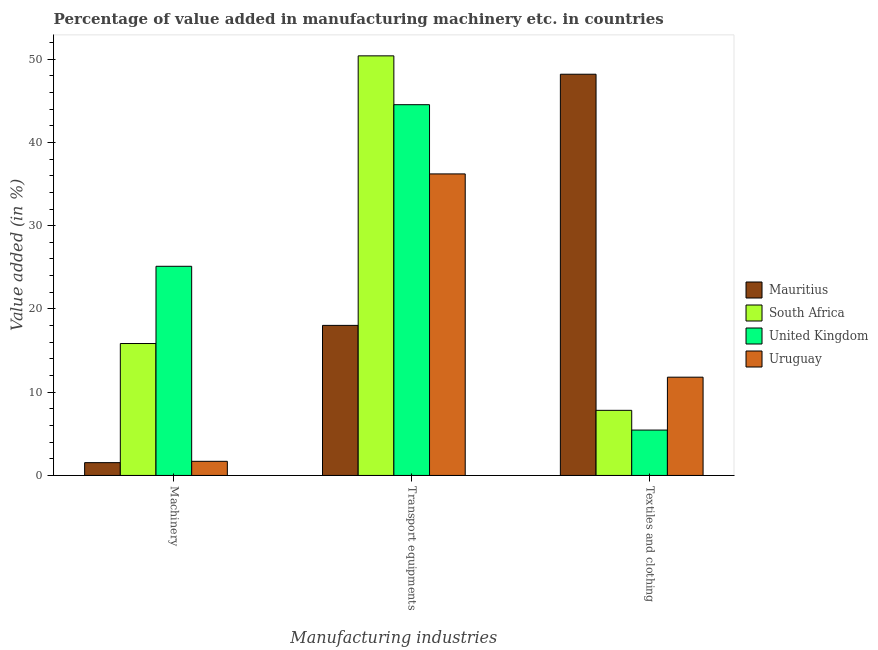Are the number of bars on each tick of the X-axis equal?
Offer a very short reply. Yes. How many bars are there on the 2nd tick from the left?
Keep it short and to the point. 4. What is the label of the 2nd group of bars from the left?
Your response must be concise. Transport equipments. What is the value added in manufacturing textile and clothing in Mauritius?
Give a very brief answer. 48.19. Across all countries, what is the maximum value added in manufacturing transport equipments?
Your answer should be very brief. 50.4. Across all countries, what is the minimum value added in manufacturing machinery?
Offer a very short reply. 1.54. In which country was the value added in manufacturing transport equipments maximum?
Ensure brevity in your answer.  South Africa. In which country was the value added in manufacturing machinery minimum?
Your answer should be compact. Mauritius. What is the total value added in manufacturing machinery in the graph?
Provide a short and direct response. 44.2. What is the difference between the value added in manufacturing transport equipments in Mauritius and that in South Africa?
Your answer should be compact. -32.38. What is the difference between the value added in manufacturing transport equipments in South Africa and the value added in manufacturing textile and clothing in Uruguay?
Your answer should be very brief. 38.6. What is the average value added in manufacturing textile and clothing per country?
Your answer should be very brief. 18.32. What is the difference between the value added in manufacturing machinery and value added in manufacturing transport equipments in Uruguay?
Your answer should be very brief. -34.52. What is the ratio of the value added in manufacturing textile and clothing in Mauritius to that in South Africa?
Ensure brevity in your answer.  6.16. What is the difference between the highest and the second highest value added in manufacturing transport equipments?
Keep it short and to the point. 5.87. What is the difference between the highest and the lowest value added in manufacturing transport equipments?
Offer a terse response. 32.38. In how many countries, is the value added in manufacturing transport equipments greater than the average value added in manufacturing transport equipments taken over all countries?
Give a very brief answer. 2. What does the 4th bar from the left in Transport equipments represents?
Provide a short and direct response. Uruguay. What does the 4th bar from the right in Machinery represents?
Your answer should be compact. Mauritius. Are all the bars in the graph horizontal?
Your answer should be very brief. No. How many countries are there in the graph?
Ensure brevity in your answer.  4. What is the difference between two consecutive major ticks on the Y-axis?
Your answer should be compact. 10. Does the graph contain any zero values?
Your answer should be compact. No. Where does the legend appear in the graph?
Provide a succinct answer. Center right. What is the title of the graph?
Provide a succinct answer. Percentage of value added in manufacturing machinery etc. in countries. What is the label or title of the X-axis?
Offer a terse response. Manufacturing industries. What is the label or title of the Y-axis?
Provide a short and direct response. Value added (in %). What is the Value added (in %) of Mauritius in Machinery?
Provide a short and direct response. 1.54. What is the Value added (in %) in South Africa in Machinery?
Provide a short and direct response. 15.85. What is the Value added (in %) in United Kingdom in Machinery?
Provide a short and direct response. 25.12. What is the Value added (in %) of Uruguay in Machinery?
Provide a short and direct response. 1.7. What is the Value added (in %) in Mauritius in Transport equipments?
Provide a succinct answer. 18.02. What is the Value added (in %) of South Africa in Transport equipments?
Provide a short and direct response. 50.4. What is the Value added (in %) in United Kingdom in Transport equipments?
Give a very brief answer. 44.53. What is the Value added (in %) in Uruguay in Transport equipments?
Provide a succinct answer. 36.22. What is the Value added (in %) in Mauritius in Textiles and clothing?
Your response must be concise. 48.19. What is the Value added (in %) in South Africa in Textiles and clothing?
Your answer should be compact. 7.82. What is the Value added (in %) of United Kingdom in Textiles and clothing?
Your answer should be compact. 5.45. What is the Value added (in %) in Uruguay in Textiles and clothing?
Provide a succinct answer. 11.8. Across all Manufacturing industries, what is the maximum Value added (in %) in Mauritius?
Offer a terse response. 48.19. Across all Manufacturing industries, what is the maximum Value added (in %) in South Africa?
Your answer should be compact. 50.4. Across all Manufacturing industries, what is the maximum Value added (in %) in United Kingdom?
Your answer should be very brief. 44.53. Across all Manufacturing industries, what is the maximum Value added (in %) in Uruguay?
Ensure brevity in your answer.  36.22. Across all Manufacturing industries, what is the minimum Value added (in %) in Mauritius?
Offer a terse response. 1.54. Across all Manufacturing industries, what is the minimum Value added (in %) in South Africa?
Your answer should be compact. 7.82. Across all Manufacturing industries, what is the minimum Value added (in %) in United Kingdom?
Your answer should be compact. 5.45. Across all Manufacturing industries, what is the minimum Value added (in %) of Uruguay?
Give a very brief answer. 1.7. What is the total Value added (in %) of Mauritius in the graph?
Provide a succinct answer. 67.75. What is the total Value added (in %) in South Africa in the graph?
Ensure brevity in your answer.  74.07. What is the total Value added (in %) in United Kingdom in the graph?
Provide a short and direct response. 75.1. What is the total Value added (in %) of Uruguay in the graph?
Provide a short and direct response. 49.72. What is the difference between the Value added (in %) of Mauritius in Machinery and that in Transport equipments?
Offer a terse response. -16.49. What is the difference between the Value added (in %) in South Africa in Machinery and that in Transport equipments?
Your response must be concise. -34.55. What is the difference between the Value added (in %) of United Kingdom in Machinery and that in Transport equipments?
Your response must be concise. -19.41. What is the difference between the Value added (in %) of Uruguay in Machinery and that in Transport equipments?
Ensure brevity in your answer.  -34.52. What is the difference between the Value added (in %) in Mauritius in Machinery and that in Textiles and clothing?
Your answer should be compact. -46.66. What is the difference between the Value added (in %) of South Africa in Machinery and that in Textiles and clothing?
Offer a very short reply. 8.03. What is the difference between the Value added (in %) in United Kingdom in Machinery and that in Textiles and clothing?
Ensure brevity in your answer.  19.67. What is the difference between the Value added (in %) of Uruguay in Machinery and that in Textiles and clothing?
Keep it short and to the point. -10.11. What is the difference between the Value added (in %) in Mauritius in Transport equipments and that in Textiles and clothing?
Make the answer very short. -30.17. What is the difference between the Value added (in %) in South Africa in Transport equipments and that in Textiles and clothing?
Provide a succinct answer. 42.58. What is the difference between the Value added (in %) in United Kingdom in Transport equipments and that in Textiles and clothing?
Your response must be concise. 39.08. What is the difference between the Value added (in %) of Uruguay in Transport equipments and that in Textiles and clothing?
Your answer should be compact. 24.42. What is the difference between the Value added (in %) in Mauritius in Machinery and the Value added (in %) in South Africa in Transport equipments?
Offer a terse response. -48.86. What is the difference between the Value added (in %) in Mauritius in Machinery and the Value added (in %) in United Kingdom in Transport equipments?
Offer a terse response. -43. What is the difference between the Value added (in %) in Mauritius in Machinery and the Value added (in %) in Uruguay in Transport equipments?
Offer a terse response. -34.68. What is the difference between the Value added (in %) in South Africa in Machinery and the Value added (in %) in United Kingdom in Transport equipments?
Offer a terse response. -28.69. What is the difference between the Value added (in %) in South Africa in Machinery and the Value added (in %) in Uruguay in Transport equipments?
Make the answer very short. -20.37. What is the difference between the Value added (in %) in United Kingdom in Machinery and the Value added (in %) in Uruguay in Transport equipments?
Provide a succinct answer. -11.1. What is the difference between the Value added (in %) of Mauritius in Machinery and the Value added (in %) of South Africa in Textiles and clothing?
Keep it short and to the point. -6.28. What is the difference between the Value added (in %) of Mauritius in Machinery and the Value added (in %) of United Kingdom in Textiles and clothing?
Ensure brevity in your answer.  -3.91. What is the difference between the Value added (in %) in Mauritius in Machinery and the Value added (in %) in Uruguay in Textiles and clothing?
Your answer should be compact. -10.27. What is the difference between the Value added (in %) in South Africa in Machinery and the Value added (in %) in United Kingdom in Textiles and clothing?
Keep it short and to the point. 10.4. What is the difference between the Value added (in %) in South Africa in Machinery and the Value added (in %) in Uruguay in Textiles and clothing?
Provide a succinct answer. 4.04. What is the difference between the Value added (in %) in United Kingdom in Machinery and the Value added (in %) in Uruguay in Textiles and clothing?
Provide a succinct answer. 13.32. What is the difference between the Value added (in %) in Mauritius in Transport equipments and the Value added (in %) in South Africa in Textiles and clothing?
Make the answer very short. 10.2. What is the difference between the Value added (in %) of Mauritius in Transport equipments and the Value added (in %) of United Kingdom in Textiles and clothing?
Ensure brevity in your answer.  12.57. What is the difference between the Value added (in %) in Mauritius in Transport equipments and the Value added (in %) in Uruguay in Textiles and clothing?
Make the answer very short. 6.22. What is the difference between the Value added (in %) in South Africa in Transport equipments and the Value added (in %) in United Kingdom in Textiles and clothing?
Your answer should be compact. 44.95. What is the difference between the Value added (in %) in South Africa in Transport equipments and the Value added (in %) in Uruguay in Textiles and clothing?
Offer a very short reply. 38.6. What is the difference between the Value added (in %) in United Kingdom in Transport equipments and the Value added (in %) in Uruguay in Textiles and clothing?
Provide a succinct answer. 32.73. What is the average Value added (in %) in Mauritius per Manufacturing industries?
Your answer should be compact. 22.58. What is the average Value added (in %) of South Africa per Manufacturing industries?
Your answer should be very brief. 24.69. What is the average Value added (in %) of United Kingdom per Manufacturing industries?
Your answer should be compact. 25.03. What is the average Value added (in %) of Uruguay per Manufacturing industries?
Offer a terse response. 16.57. What is the difference between the Value added (in %) of Mauritius and Value added (in %) of South Africa in Machinery?
Keep it short and to the point. -14.31. What is the difference between the Value added (in %) of Mauritius and Value added (in %) of United Kingdom in Machinery?
Your answer should be very brief. -23.59. What is the difference between the Value added (in %) in Mauritius and Value added (in %) in Uruguay in Machinery?
Give a very brief answer. -0.16. What is the difference between the Value added (in %) of South Africa and Value added (in %) of United Kingdom in Machinery?
Your answer should be very brief. -9.28. What is the difference between the Value added (in %) in South Africa and Value added (in %) in Uruguay in Machinery?
Keep it short and to the point. 14.15. What is the difference between the Value added (in %) of United Kingdom and Value added (in %) of Uruguay in Machinery?
Your answer should be compact. 23.43. What is the difference between the Value added (in %) of Mauritius and Value added (in %) of South Africa in Transport equipments?
Offer a terse response. -32.38. What is the difference between the Value added (in %) in Mauritius and Value added (in %) in United Kingdom in Transport equipments?
Give a very brief answer. -26.51. What is the difference between the Value added (in %) in Mauritius and Value added (in %) in Uruguay in Transport equipments?
Provide a short and direct response. -18.19. What is the difference between the Value added (in %) of South Africa and Value added (in %) of United Kingdom in Transport equipments?
Keep it short and to the point. 5.87. What is the difference between the Value added (in %) in South Africa and Value added (in %) in Uruguay in Transport equipments?
Your response must be concise. 14.18. What is the difference between the Value added (in %) of United Kingdom and Value added (in %) of Uruguay in Transport equipments?
Provide a short and direct response. 8.31. What is the difference between the Value added (in %) of Mauritius and Value added (in %) of South Africa in Textiles and clothing?
Provide a short and direct response. 40.37. What is the difference between the Value added (in %) of Mauritius and Value added (in %) of United Kingdom in Textiles and clothing?
Give a very brief answer. 42.74. What is the difference between the Value added (in %) in Mauritius and Value added (in %) in Uruguay in Textiles and clothing?
Provide a short and direct response. 36.39. What is the difference between the Value added (in %) in South Africa and Value added (in %) in United Kingdom in Textiles and clothing?
Offer a terse response. 2.37. What is the difference between the Value added (in %) of South Africa and Value added (in %) of Uruguay in Textiles and clothing?
Keep it short and to the point. -3.98. What is the difference between the Value added (in %) of United Kingdom and Value added (in %) of Uruguay in Textiles and clothing?
Keep it short and to the point. -6.35. What is the ratio of the Value added (in %) in Mauritius in Machinery to that in Transport equipments?
Ensure brevity in your answer.  0.09. What is the ratio of the Value added (in %) in South Africa in Machinery to that in Transport equipments?
Provide a short and direct response. 0.31. What is the ratio of the Value added (in %) of United Kingdom in Machinery to that in Transport equipments?
Provide a short and direct response. 0.56. What is the ratio of the Value added (in %) of Uruguay in Machinery to that in Transport equipments?
Keep it short and to the point. 0.05. What is the ratio of the Value added (in %) of Mauritius in Machinery to that in Textiles and clothing?
Ensure brevity in your answer.  0.03. What is the ratio of the Value added (in %) in South Africa in Machinery to that in Textiles and clothing?
Provide a succinct answer. 2.03. What is the ratio of the Value added (in %) of United Kingdom in Machinery to that in Textiles and clothing?
Your answer should be compact. 4.61. What is the ratio of the Value added (in %) of Uruguay in Machinery to that in Textiles and clothing?
Keep it short and to the point. 0.14. What is the ratio of the Value added (in %) in Mauritius in Transport equipments to that in Textiles and clothing?
Ensure brevity in your answer.  0.37. What is the ratio of the Value added (in %) of South Africa in Transport equipments to that in Textiles and clothing?
Keep it short and to the point. 6.44. What is the ratio of the Value added (in %) of United Kingdom in Transport equipments to that in Textiles and clothing?
Ensure brevity in your answer.  8.17. What is the ratio of the Value added (in %) in Uruguay in Transport equipments to that in Textiles and clothing?
Ensure brevity in your answer.  3.07. What is the difference between the highest and the second highest Value added (in %) in Mauritius?
Your answer should be very brief. 30.17. What is the difference between the highest and the second highest Value added (in %) in South Africa?
Give a very brief answer. 34.55. What is the difference between the highest and the second highest Value added (in %) of United Kingdom?
Offer a terse response. 19.41. What is the difference between the highest and the second highest Value added (in %) of Uruguay?
Make the answer very short. 24.42. What is the difference between the highest and the lowest Value added (in %) of Mauritius?
Your answer should be very brief. 46.66. What is the difference between the highest and the lowest Value added (in %) of South Africa?
Your answer should be very brief. 42.58. What is the difference between the highest and the lowest Value added (in %) in United Kingdom?
Offer a terse response. 39.08. What is the difference between the highest and the lowest Value added (in %) of Uruguay?
Keep it short and to the point. 34.52. 